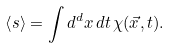Convert formula to latex. <formula><loc_0><loc_0><loc_500><loc_500>\left < s \right > = \int d ^ { d } x \, d t \, \chi ( \vec { x } , t ) .</formula> 